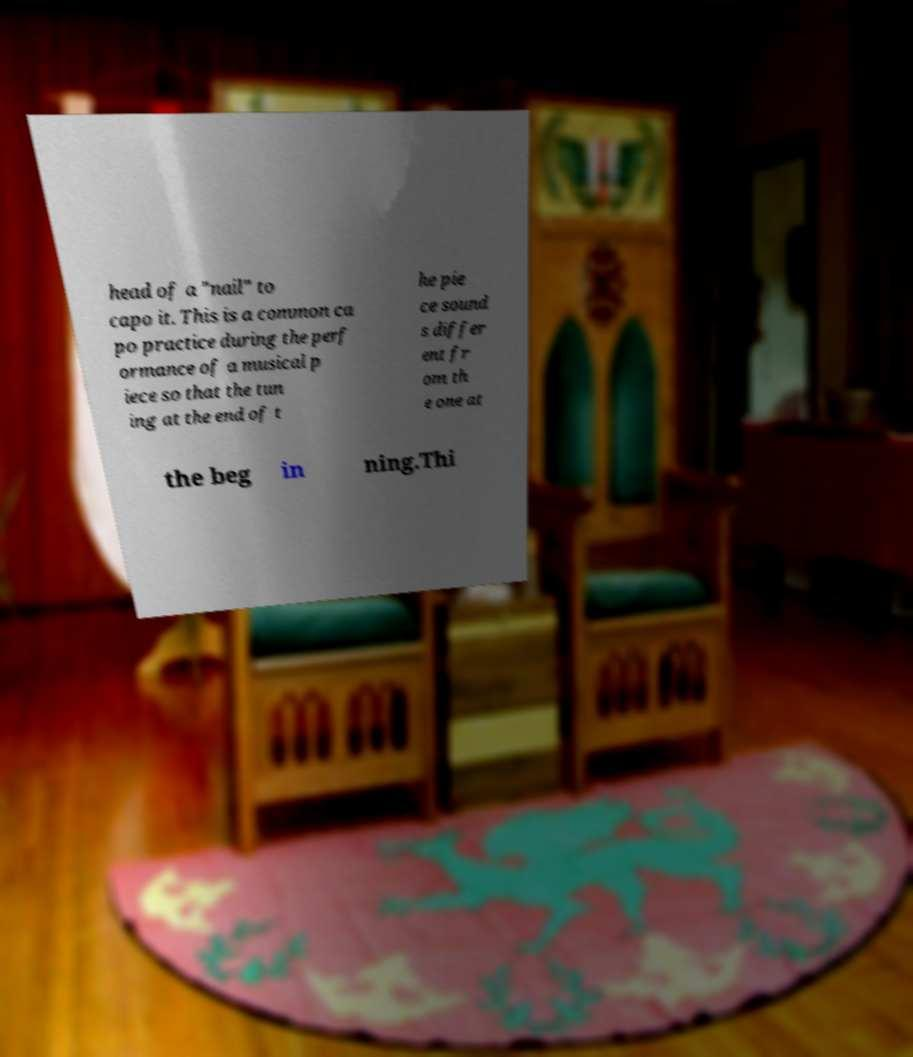Could you assist in decoding the text presented in this image and type it out clearly? head of a "nail" to capo it. This is a common ca po practice during the perf ormance of a musical p iece so that the tun ing at the end of t he pie ce sound s differ ent fr om th e one at the beg in ning.Thi 